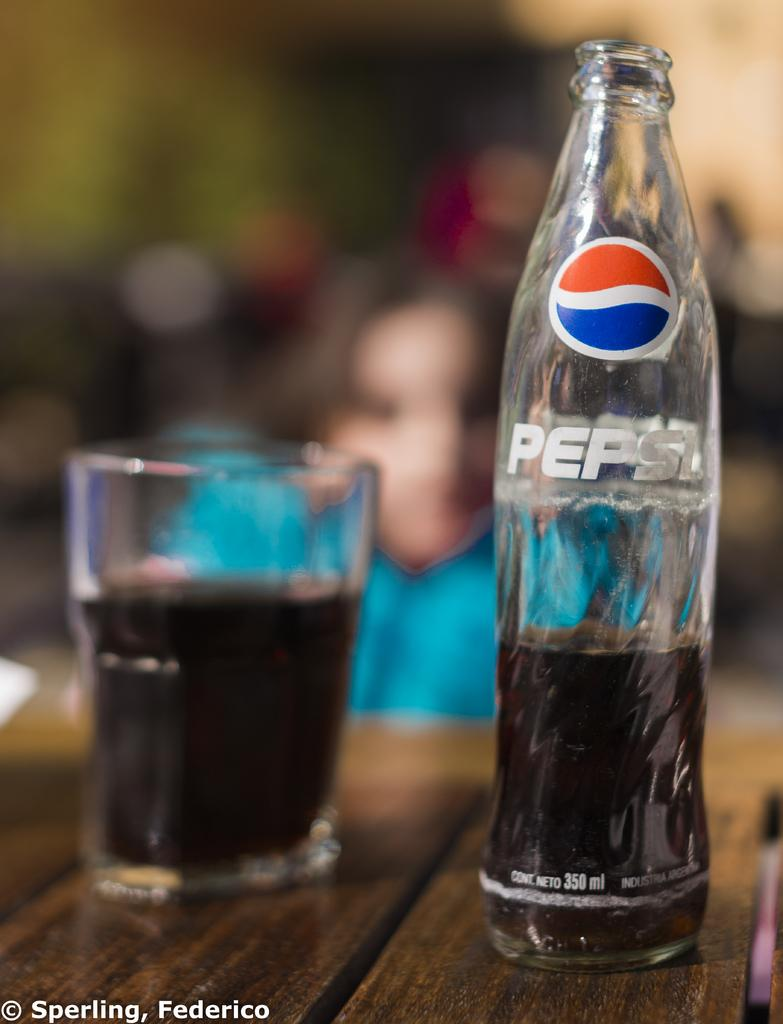<image>
Offer a succinct explanation of the picture presented. Glass with a bottle of PEPSI sitting in front of a girl on the table. 